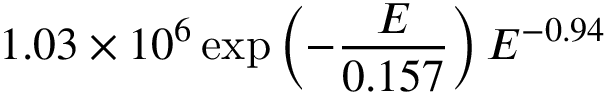<formula> <loc_0><loc_0><loc_500><loc_500>1 . 0 3 \times 1 0 ^ { 6 } \exp \left ( - \frac { E } { 0 . 1 5 7 } \right ) E ^ { - 0 . 9 4 }</formula> 